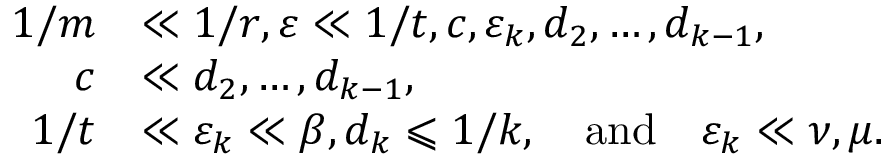Convert formula to latex. <formula><loc_0><loc_0><loc_500><loc_500>\begin{array} { r l } { 1 / m } & { \ll 1 / r , \varepsilon \ll 1 / t , c , \varepsilon _ { k } , d _ { 2 } , \dots , d _ { k - 1 } , } \\ { c } & { \ll d _ { 2 } , \dots , d _ { k - 1 } , } \\ { 1 / t } & { \ll \varepsilon _ { k } \ll \beta , d _ { k } \leqslant 1 / k , \quad a n d \quad \varepsilon _ { k } \ll \nu , \mu . } \end{array}</formula> 